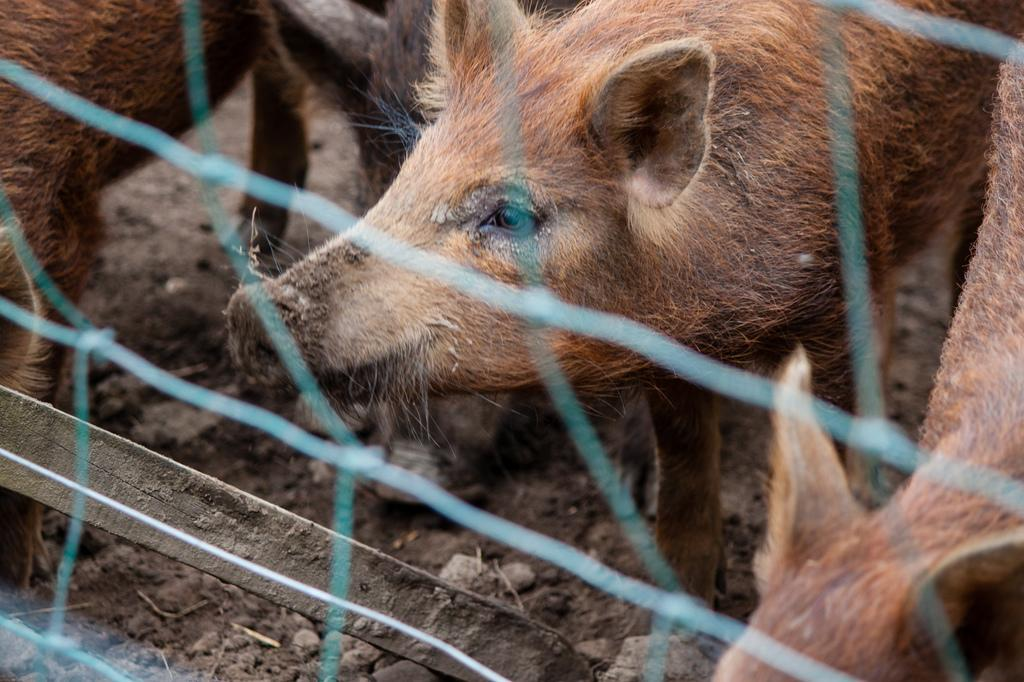What is present in the image that is used for catching or holding objects? There is a net in the image. What type of animals can be seen in the image? There are pigs in the image. What is the surface on which the pigs are standing? The pigs are on mud. What type of apparel is the pig wearing in the image? There is no apparel present on the pigs in the image; they are on mud. What disease can be seen affecting the pigs in the image? There is no disease visible in the image; the pigs are simply standing on mud. 